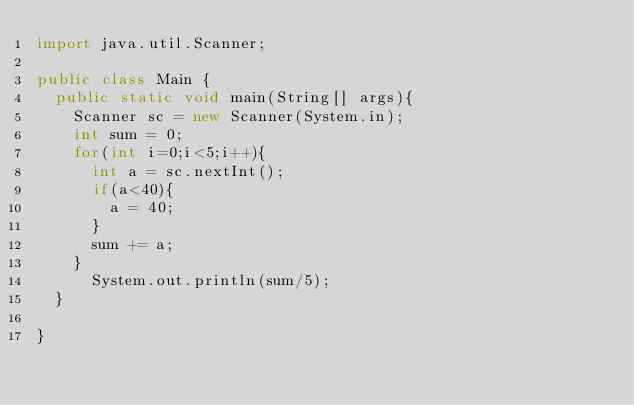<code> <loc_0><loc_0><loc_500><loc_500><_Java_>import java.util.Scanner;

public class Main {
	public static void main(String[] args){
		Scanner sc = new Scanner(System.in);
		int sum = 0;
		for(int i=0;i<5;i++){
			int a = sc.nextInt();
			if(a<40){
				a = 40;
			}
			sum += a;
		}
	    System.out.println(sum/5);
	}

}</code> 